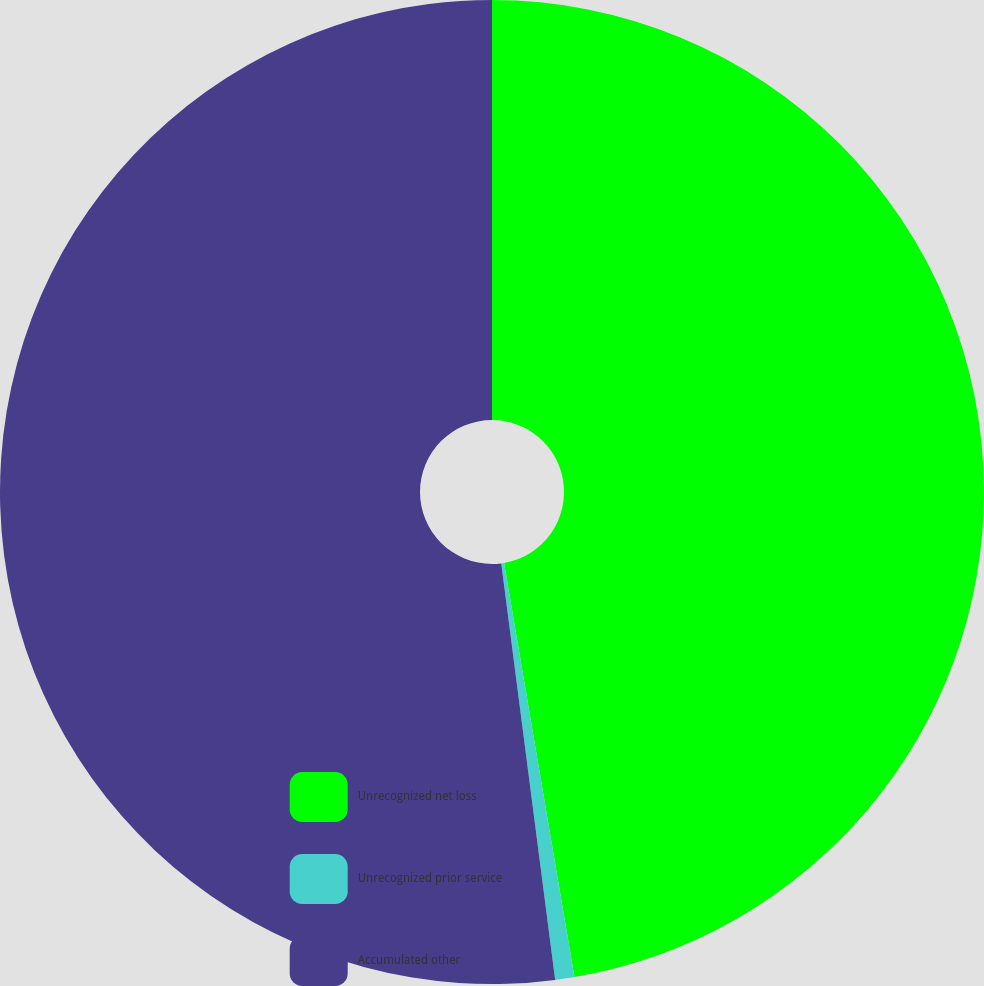Convert chart to OTSL. <chart><loc_0><loc_0><loc_500><loc_500><pie_chart><fcel>Unrecognized net loss<fcel>Unrecognized prior service<fcel>Accumulated other<nl><fcel>47.32%<fcel>0.63%<fcel>52.05%<nl></chart> 